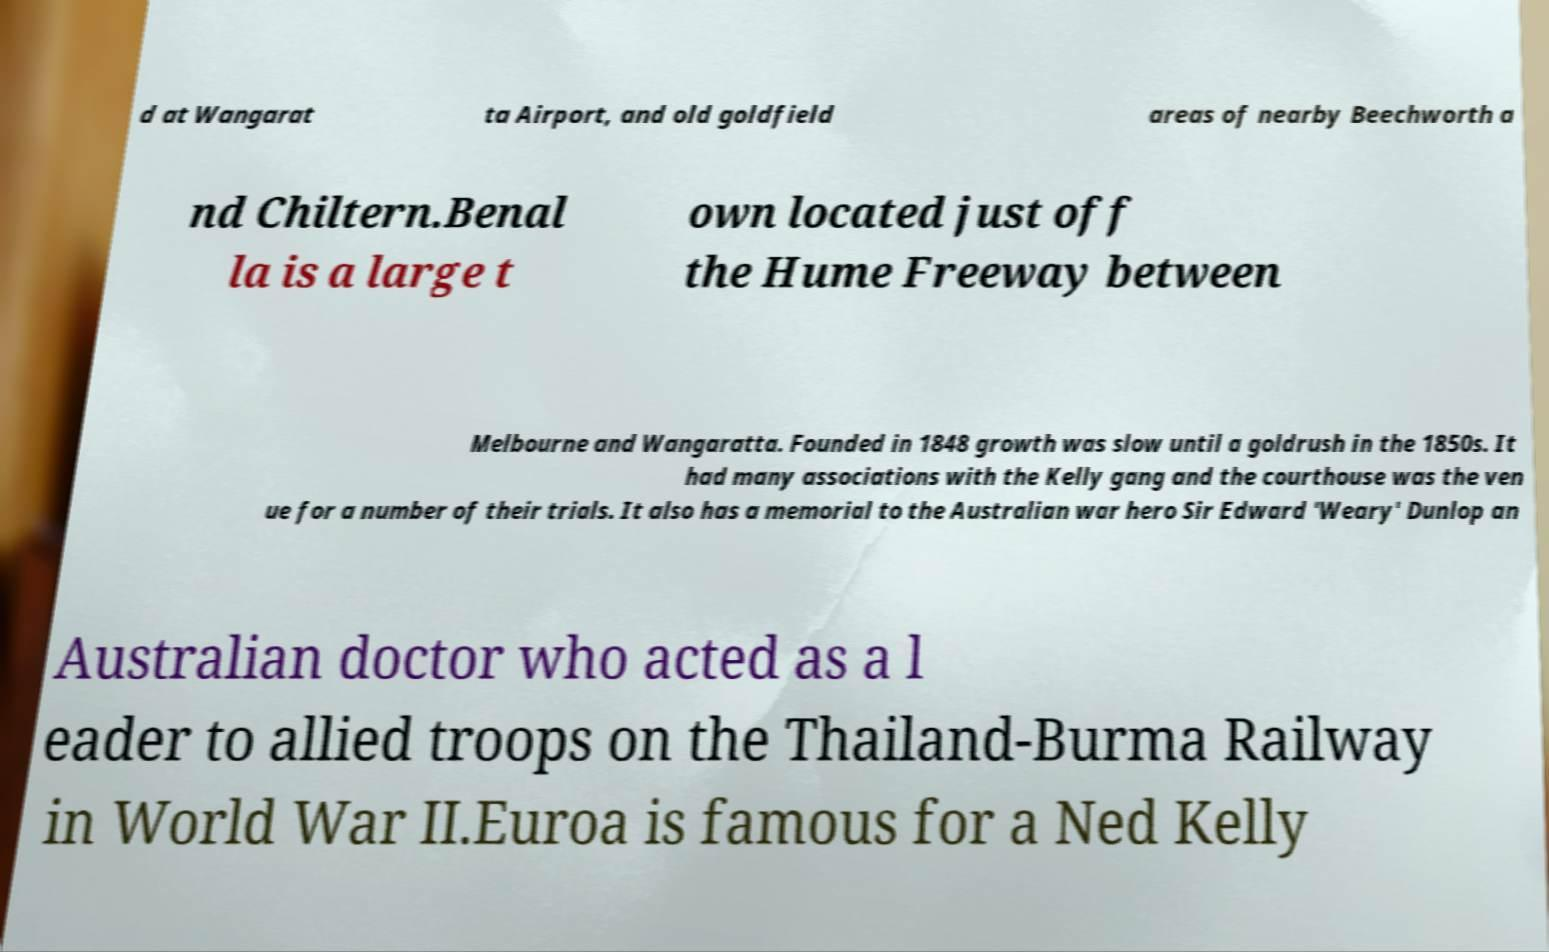For documentation purposes, I need the text within this image transcribed. Could you provide that? d at Wangarat ta Airport, and old goldfield areas of nearby Beechworth a nd Chiltern.Benal la is a large t own located just off the Hume Freeway between Melbourne and Wangaratta. Founded in 1848 growth was slow until a goldrush in the 1850s. It had many associations with the Kelly gang and the courthouse was the ven ue for a number of their trials. It also has a memorial to the Australian war hero Sir Edward 'Weary' Dunlop an Australian doctor who acted as a l eader to allied troops on the Thailand-Burma Railway in World War II.Euroa is famous for a Ned Kelly 